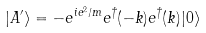Convert formula to latex. <formula><loc_0><loc_0><loc_500><loc_500>| A ^ { \prime } \rangle = - e ^ { i e ^ { 2 } / m } e ^ { \dagger } ( - { k } ) e ^ { \dagger } ( { k } ) | 0 \rangle</formula> 